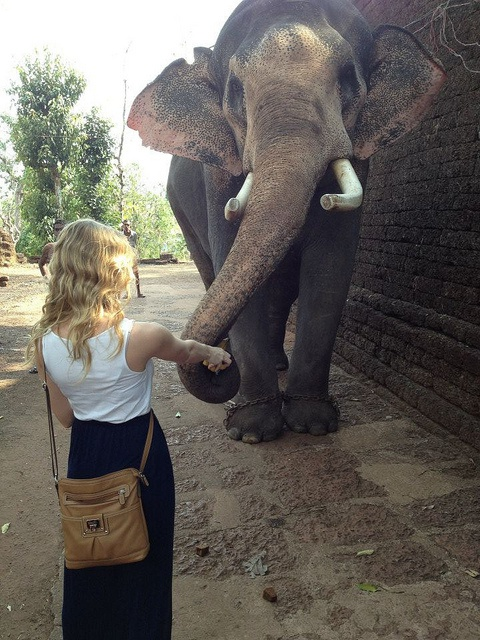Describe the objects in this image and their specific colors. I can see elephant in white, gray, black, and darkgray tones, people in white, black, gray, maroon, and darkgray tones, handbag in white, maroon, gray, and black tones, and people in white, gray, darkgray, and beige tones in this image. 